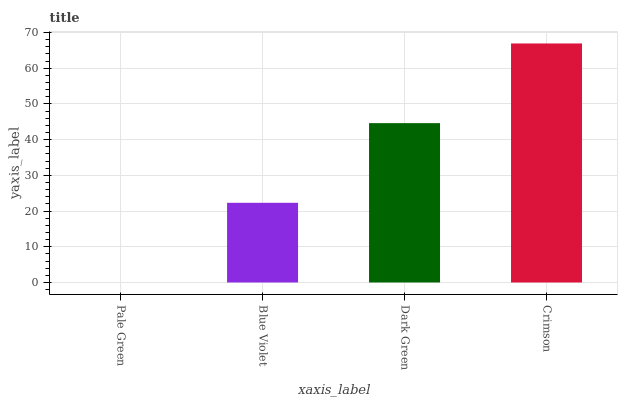Is Pale Green the minimum?
Answer yes or no. Yes. Is Crimson the maximum?
Answer yes or no. Yes. Is Blue Violet the minimum?
Answer yes or no. No. Is Blue Violet the maximum?
Answer yes or no. No. Is Blue Violet greater than Pale Green?
Answer yes or no. Yes. Is Pale Green less than Blue Violet?
Answer yes or no. Yes. Is Pale Green greater than Blue Violet?
Answer yes or no. No. Is Blue Violet less than Pale Green?
Answer yes or no. No. Is Dark Green the high median?
Answer yes or no. Yes. Is Blue Violet the low median?
Answer yes or no. Yes. Is Pale Green the high median?
Answer yes or no. No. Is Crimson the low median?
Answer yes or no. No. 